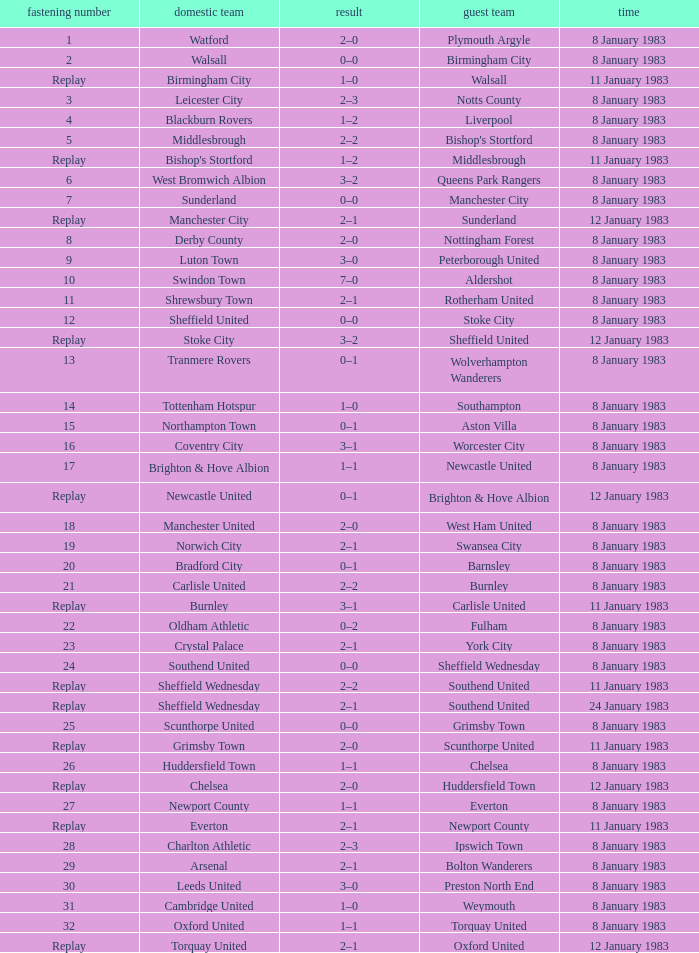For which tie was Scunthorpe United the away team? Replay. 